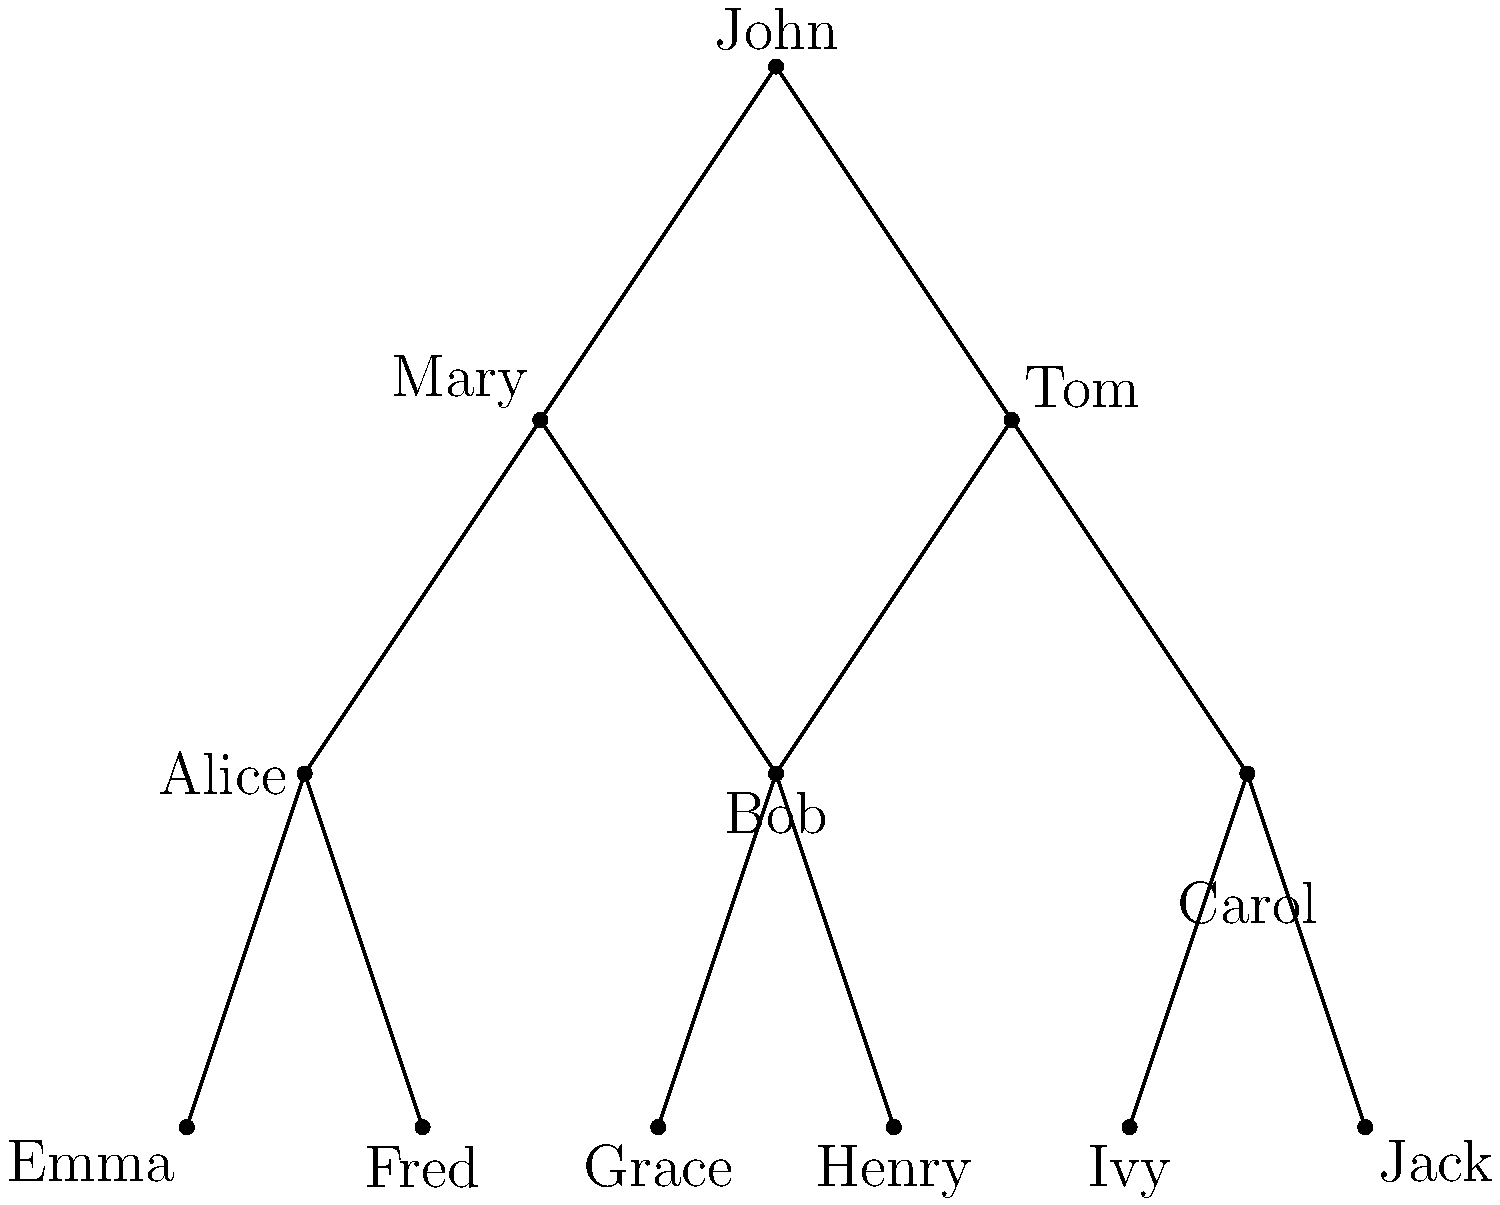In the family tree diagram above, John is seeking custody of his grandchild, Emma. According to most jurisdictions' laws, grandparents may seek custody if the child's parents are deceased, incompetent, or incarcerated. Given that Emma's mother (Alice) is deceased and her father (Fred) is incarcerated, how many of John's grandchildren would he potentially be eligible to seek custody for under similar circumstances? To determine how many grandchildren John might be eligible to seek custody for, we need to analyze the family tree and apply the given conditions. Let's go through this step-by-step:

1. Identify John's children:
   - John has three children: Mary, Tom, and Carol.

2. Identify John's grandchildren:
   - Mary's children: Emma and Fred
   - Tom's children: Grace and Henry
   - Carol's children: Ivy and Jack

3. Apply the custody eligibility conditions:
   - For each grandchild, we need to check if both parents are either deceased, incompetent, or incarcerated.

4. Analyze each set of grandchildren:
   - Emma and Fred: 
     Emma's mother (Alice) is deceased, and her father (Fred) is incarcerated. Emma meets the criteria.
     Fred is John's grandchild but also Emma's father, so he doesn't qualify as a minor for custody.
   
   - Grace and Henry:
     Their parents (Tom and Bob) are still alive and presumably competent and free. They don't meet the criteria.
   
   - Ivy and Jack:
     Their parents (Carol and an unnamed spouse) are still alive and presumably competent and free. They don't meet the criteria.

5. Count the eligible grandchildren:
   - Only Emma meets the criteria for John to potentially seek custody.

Therefore, out of all his grandchildren, John would potentially be eligible to seek custody for 1 grandchild (Emma) under similar circumstances.
Answer: 1 grandchild 